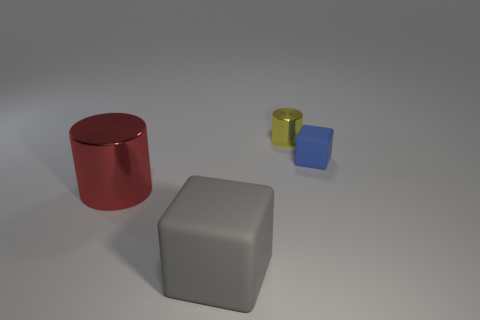What is the material of the other object that is the same shape as the tiny matte object?
Offer a terse response. Rubber. There is another gray cube that is the same material as the small cube; what size is it?
Provide a short and direct response. Large. What color is the other object that is the same size as the yellow metallic thing?
Your answer should be compact. Blue. What is the color of the large cylinder?
Your answer should be very brief. Red. There is a thing left of the big gray thing; what material is it?
Your response must be concise. Metal. What size is the gray thing that is the same shape as the blue matte thing?
Offer a terse response. Large. Is the number of large cubes behind the red thing less than the number of small gray matte objects?
Your response must be concise. No. Are any tiny brown cubes visible?
Your answer should be compact. No. There is another big object that is the same shape as the blue matte thing; what is its color?
Offer a terse response. Gray. There is a object behind the blue cube; is it the same color as the large cube?
Make the answer very short. No. 